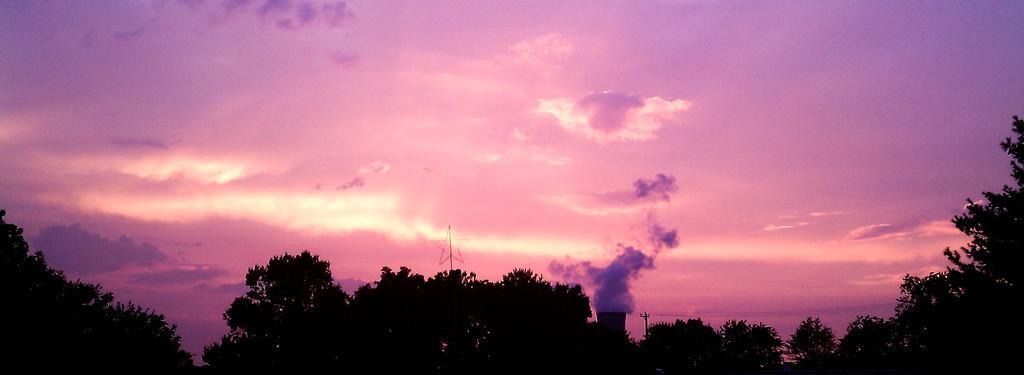Describe this image in one or two sentences. In this image we can see many trees. We can also see the electrical pole with wires, a tower with the smoke and also the star. In the background we can see the sky with the clouds. 